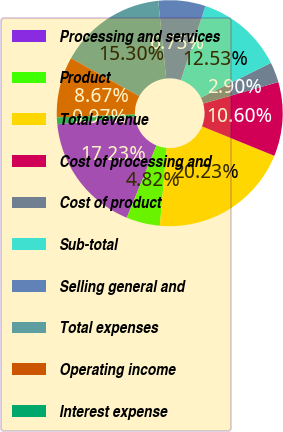Convert chart. <chart><loc_0><loc_0><loc_500><loc_500><pie_chart><fcel>Processing and services<fcel>Product<fcel>Total revenue<fcel>Cost of processing and<fcel>Cost of product<fcel>Sub-total<fcel>Selling general and<fcel>Total expenses<fcel>Operating income<fcel>Interest expense<nl><fcel>17.23%<fcel>4.82%<fcel>20.23%<fcel>10.6%<fcel>2.9%<fcel>12.53%<fcel>6.75%<fcel>15.3%<fcel>8.67%<fcel>0.97%<nl></chart> 